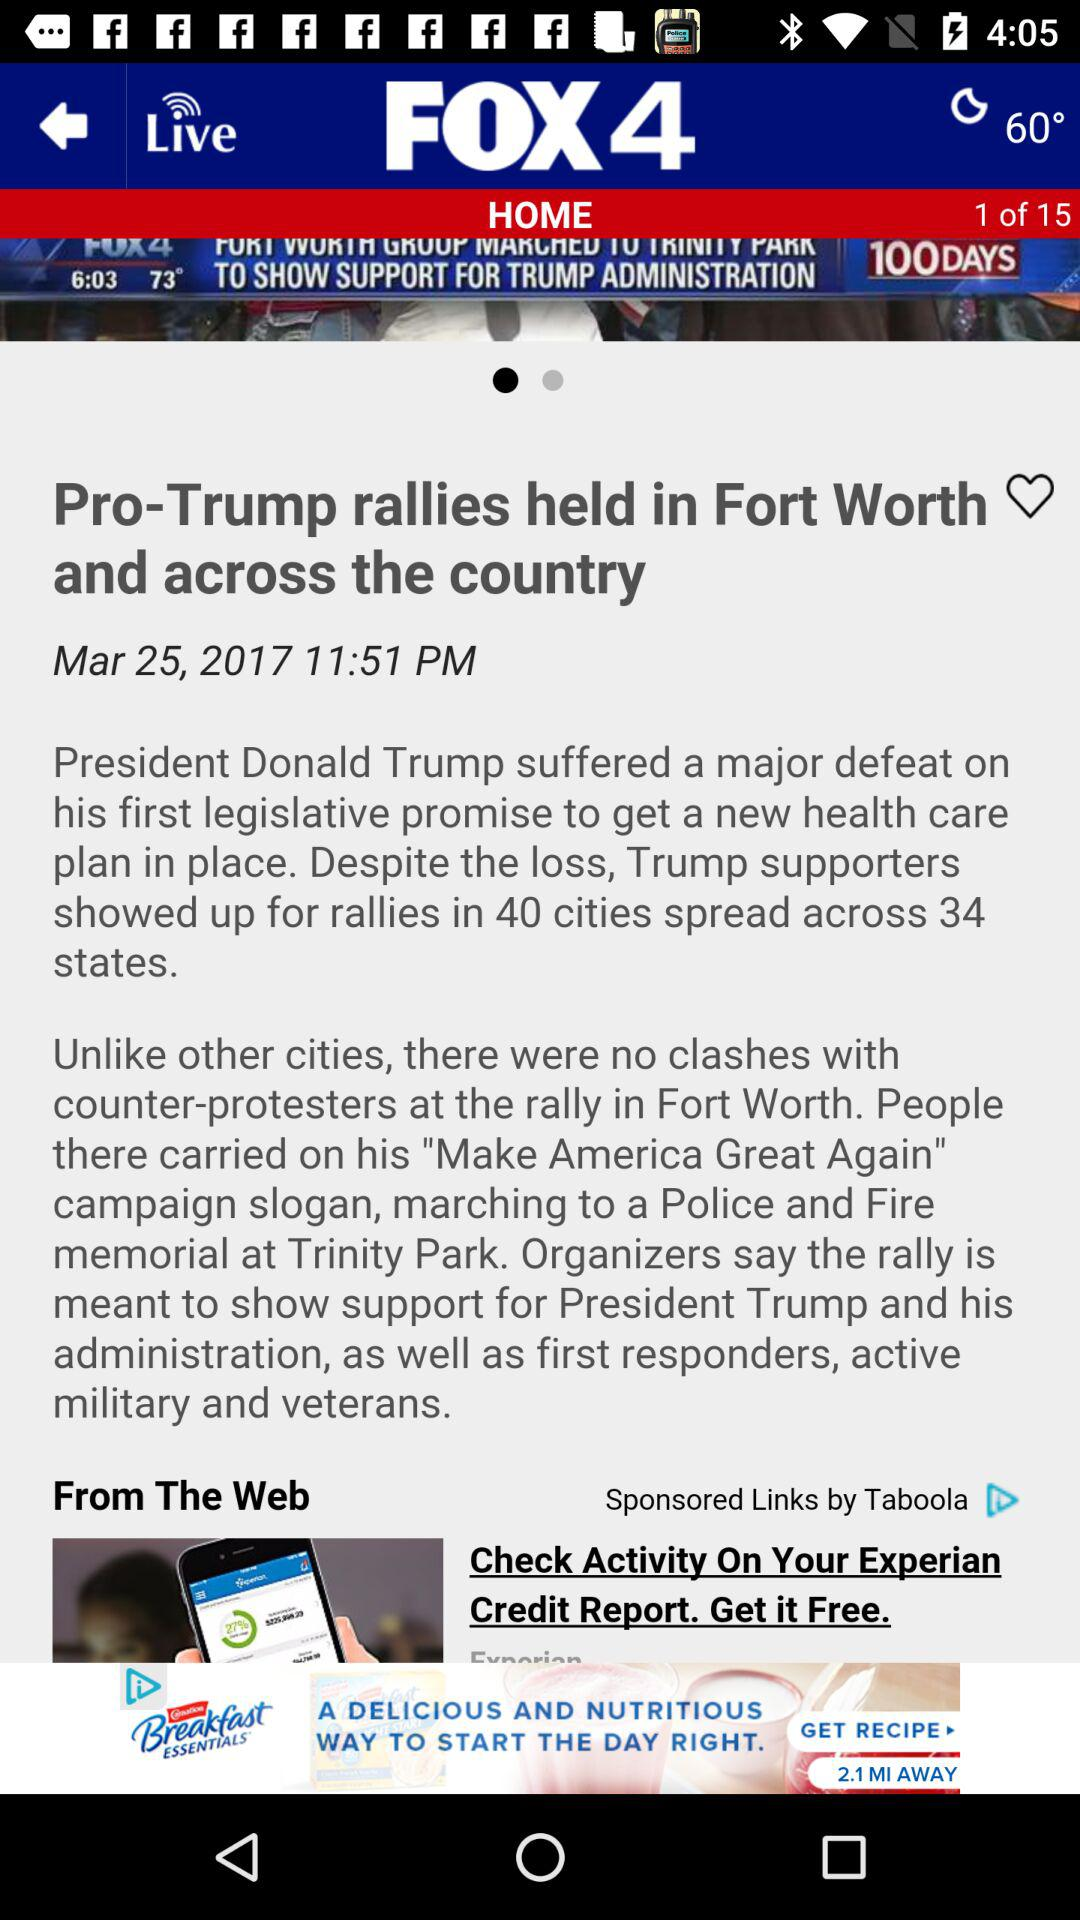What is the news channel's name? The news channel's name is "FOX 4". 